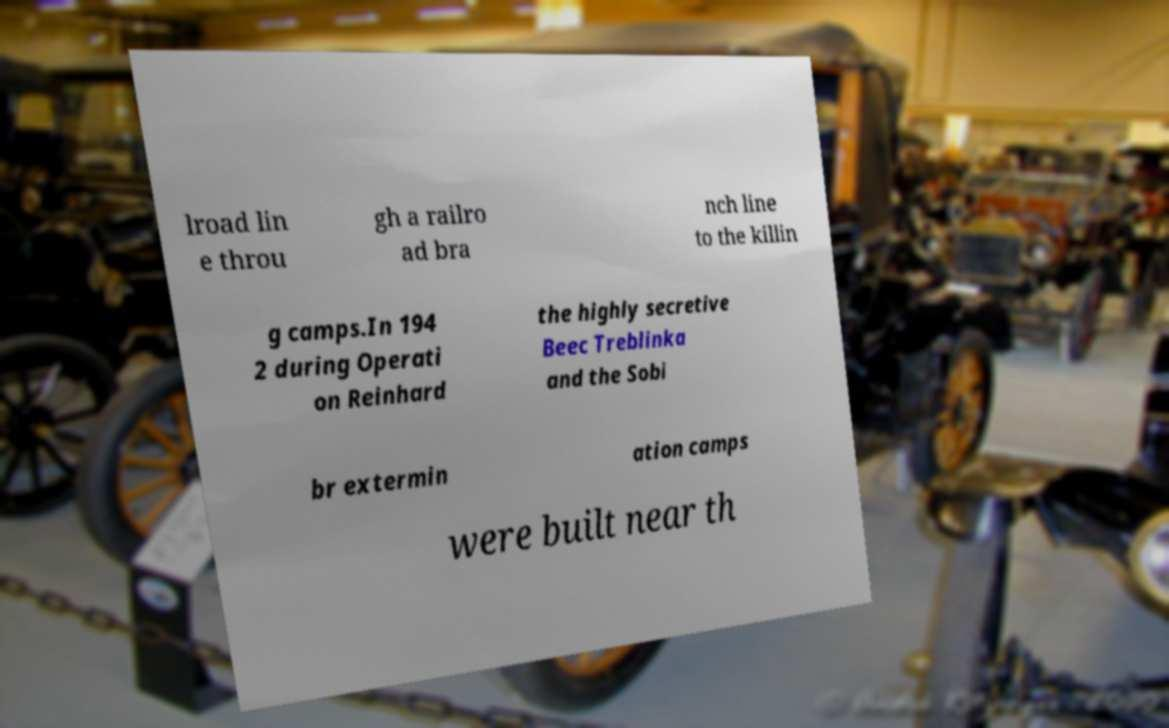Can you accurately transcribe the text from the provided image for me? lroad lin e throu gh a railro ad bra nch line to the killin g camps.In 194 2 during Operati on Reinhard the highly secretive Beec Treblinka and the Sobi br extermin ation camps were built near th 